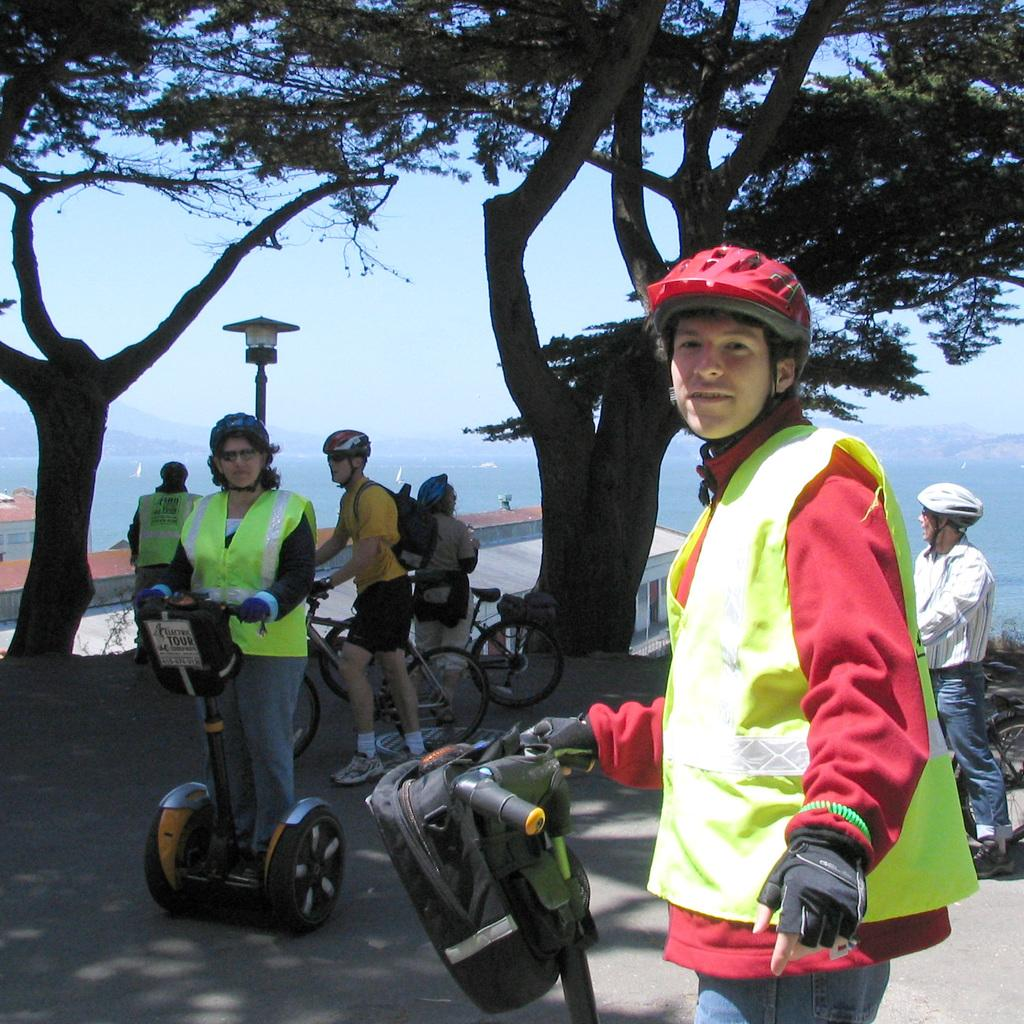What are the people in the image doing? People are standing on the sidewalk and on the road while holding bicycles. What can be seen on the street pole in the image? The facts do not mention anything specific about the street pole. What type of lighting is present in the image? There is a street light in the image. What type of vegetation is visible in the image? Trees are visible in the image. What type of structures are present in the image? Buildings are present in the image. What type of geographical feature is visible in the image? Hills are visible in the image. What part of the natural environment is visible in the image? The sky is visible in the image. Can you see a boat in the image? No, there is no boat present in the image. What type of industry is depicted in the image? There is no industry depicted in the image; it features people standing on the sidewalk and road while holding bicycles, a street pole, a street light, trees, buildings, hills, and the sky. 